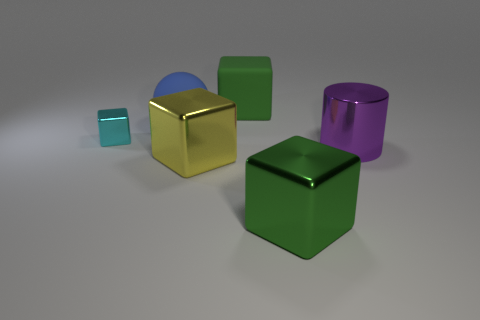What is the shape of the big rubber thing that is to the right of the yellow shiny object? The big rubber item to the right of the yellow shiny object appears to be a cylinder, not a cube. Its surface seems to have a matte finish, indicative of rubber material, and its elongated circular shape is characteristic of a cylindrical object. 